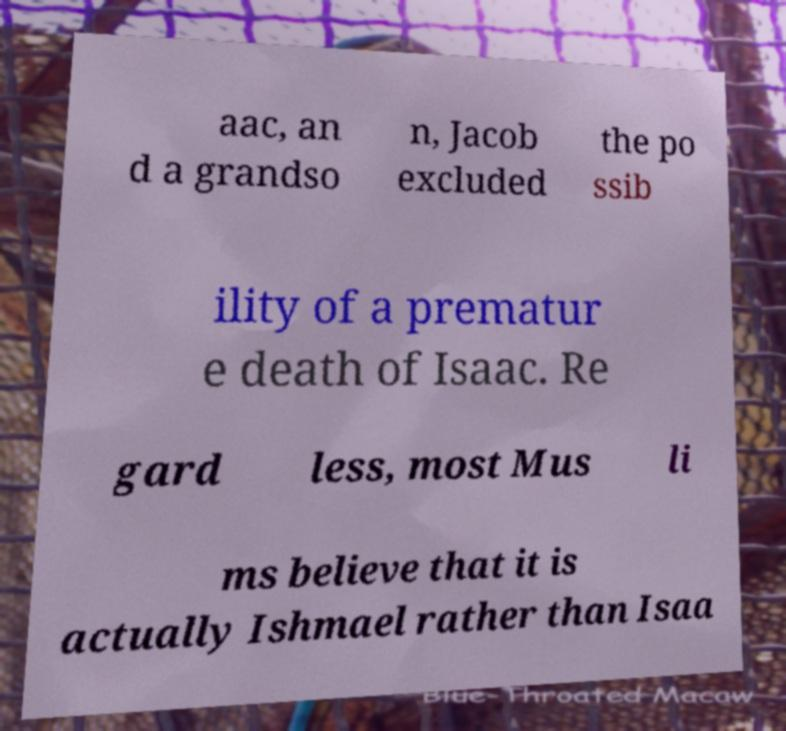Could you extract and type out the text from this image? aac, an d a grandso n, Jacob excluded the po ssib ility of a prematur e death of Isaac. Re gard less, most Mus li ms believe that it is actually Ishmael rather than Isaa 